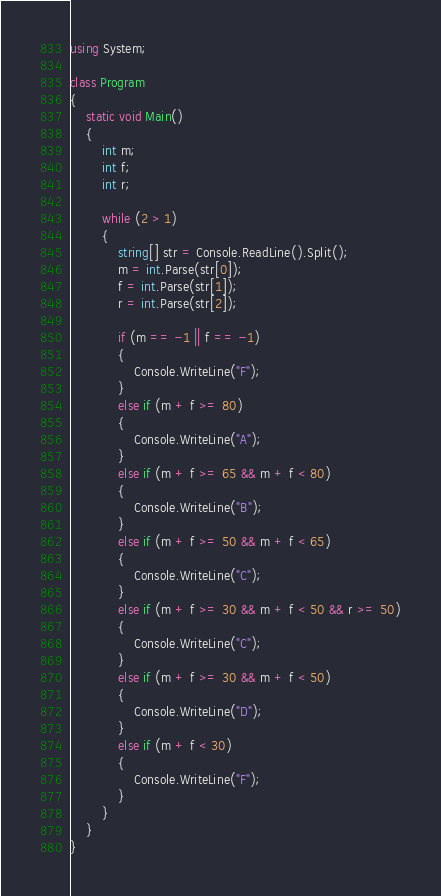Convert code to text. <code><loc_0><loc_0><loc_500><loc_500><_C#_>using System;

class Program
{
    static void Main()
    {
        int m;
        int f;
        int r;

        while (2 > 1)
        {
            string[] str = Console.ReadLine().Split();
            m = int.Parse(str[0]);
            f = int.Parse(str[1]);
            r = int.Parse(str[2]);

            if (m == -1 || f == -1)
            {
                Console.WriteLine("F");
            }
            else if (m + f >= 80)
            {
                Console.WriteLine("A");
            }
            else if (m + f >= 65 && m + f < 80)
            {
                Console.WriteLine("B");
            }
            else if (m + f >= 50 && m + f < 65)
            {
                Console.WriteLine("C");
            }
            else if (m + f >= 30 && m + f < 50 && r >= 50)
            {
                Console.WriteLine("C");
            }
            else if (m + f >= 30 && m + f < 50)
            {
                Console.WriteLine("D");
            }
            else if (m + f < 30)
            {
                Console.WriteLine("F");
            }
        }
    }
}</code> 